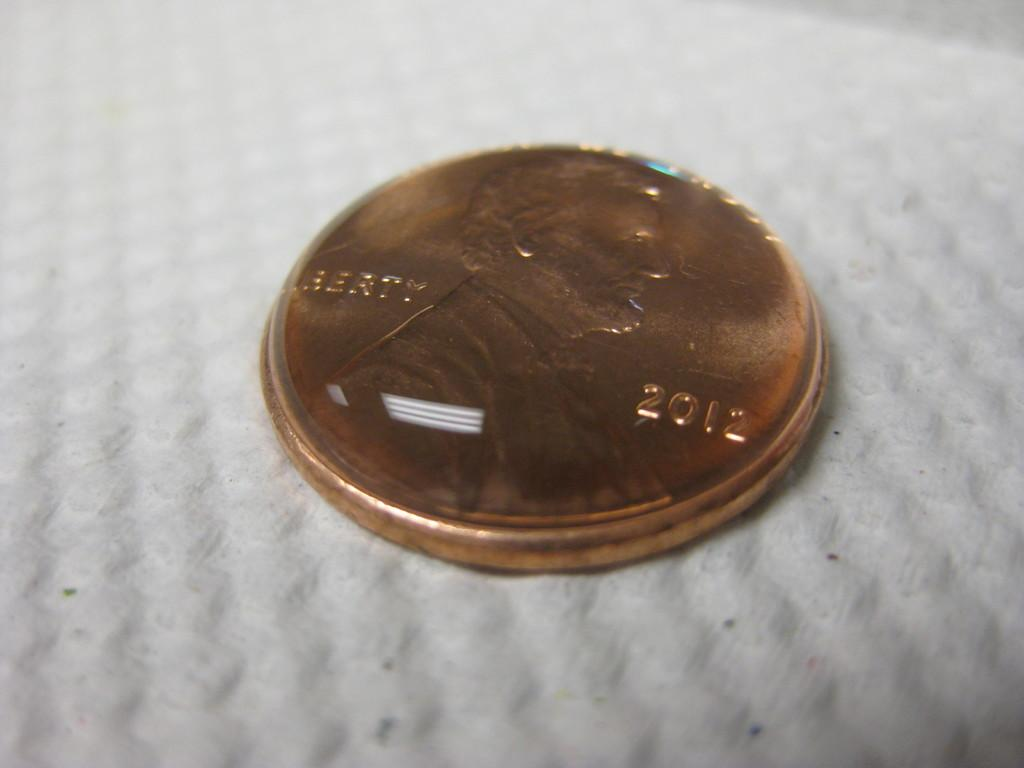<image>
Write a terse but informative summary of the picture. a close up of a 2012 minted penny that reads Liberty on it 